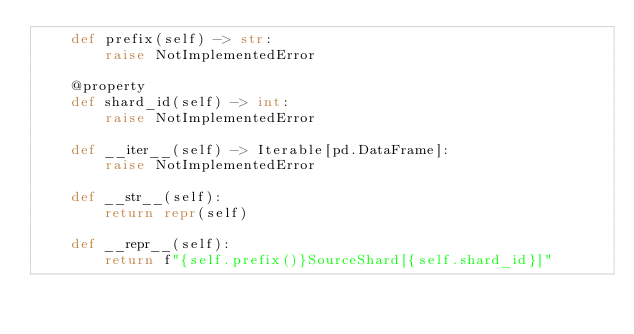Convert code to text. <code><loc_0><loc_0><loc_500><loc_500><_Python_>    def prefix(self) -> str:
        raise NotImplementedError

    @property
    def shard_id(self) -> int:
        raise NotImplementedError

    def __iter__(self) -> Iterable[pd.DataFrame]:
        raise NotImplementedError

    def __str__(self):
        return repr(self)

    def __repr__(self):
        return f"{self.prefix()}SourceShard[{self.shard_id}]"
</code> 